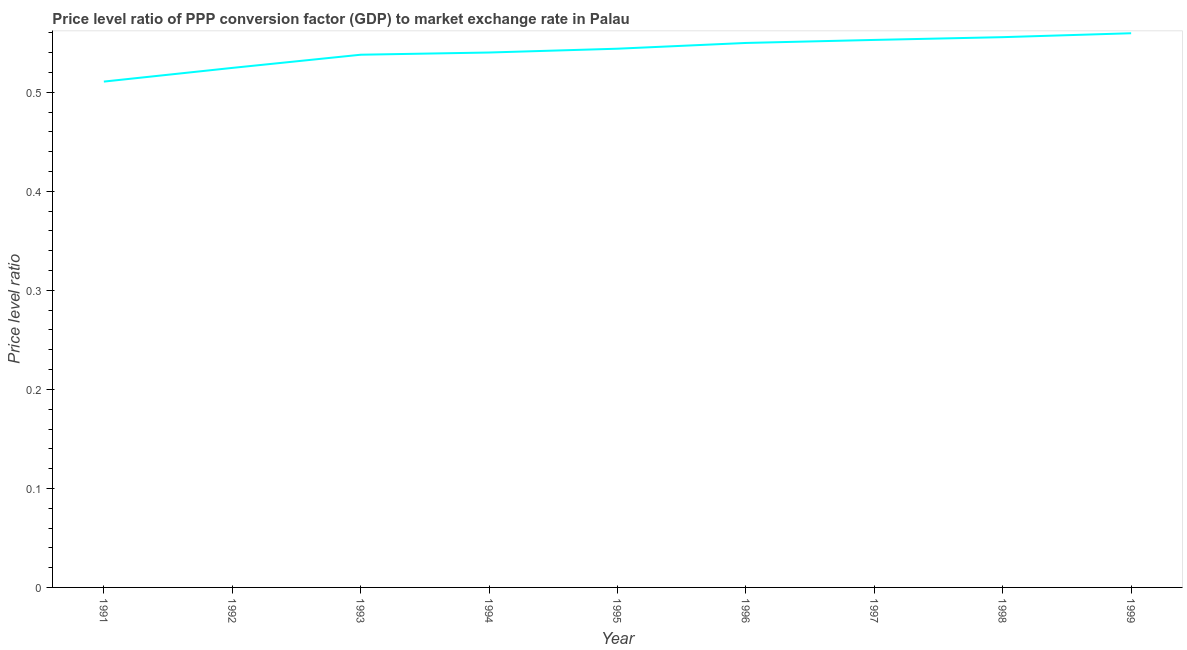What is the price level ratio in 1996?
Your answer should be very brief. 0.55. Across all years, what is the maximum price level ratio?
Offer a terse response. 0.56. Across all years, what is the minimum price level ratio?
Give a very brief answer. 0.51. In which year was the price level ratio minimum?
Offer a terse response. 1991. What is the sum of the price level ratio?
Keep it short and to the point. 4.88. What is the difference between the price level ratio in 1992 and 1995?
Your response must be concise. -0.02. What is the average price level ratio per year?
Make the answer very short. 0.54. What is the median price level ratio?
Offer a terse response. 0.54. What is the ratio of the price level ratio in 1995 to that in 1996?
Your answer should be compact. 0.99. Is the difference between the price level ratio in 1993 and 1997 greater than the difference between any two years?
Your answer should be compact. No. What is the difference between the highest and the second highest price level ratio?
Your answer should be very brief. 0. What is the difference between the highest and the lowest price level ratio?
Your answer should be very brief. 0.05. Does the price level ratio monotonically increase over the years?
Give a very brief answer. Yes. What is the difference between two consecutive major ticks on the Y-axis?
Your response must be concise. 0.1. Are the values on the major ticks of Y-axis written in scientific E-notation?
Ensure brevity in your answer.  No. What is the title of the graph?
Provide a succinct answer. Price level ratio of PPP conversion factor (GDP) to market exchange rate in Palau. What is the label or title of the Y-axis?
Provide a succinct answer. Price level ratio. What is the Price level ratio of 1991?
Your answer should be compact. 0.51. What is the Price level ratio in 1992?
Your answer should be very brief. 0.52. What is the Price level ratio of 1993?
Provide a succinct answer. 0.54. What is the Price level ratio of 1994?
Your response must be concise. 0.54. What is the Price level ratio of 1995?
Keep it short and to the point. 0.54. What is the Price level ratio of 1996?
Give a very brief answer. 0.55. What is the Price level ratio of 1997?
Your response must be concise. 0.55. What is the Price level ratio of 1998?
Your response must be concise. 0.56. What is the Price level ratio in 1999?
Your answer should be very brief. 0.56. What is the difference between the Price level ratio in 1991 and 1992?
Your response must be concise. -0.01. What is the difference between the Price level ratio in 1991 and 1993?
Your response must be concise. -0.03. What is the difference between the Price level ratio in 1991 and 1994?
Offer a very short reply. -0.03. What is the difference between the Price level ratio in 1991 and 1995?
Your response must be concise. -0.03. What is the difference between the Price level ratio in 1991 and 1996?
Provide a succinct answer. -0.04. What is the difference between the Price level ratio in 1991 and 1997?
Your answer should be very brief. -0.04. What is the difference between the Price level ratio in 1991 and 1998?
Offer a terse response. -0.04. What is the difference between the Price level ratio in 1991 and 1999?
Provide a short and direct response. -0.05. What is the difference between the Price level ratio in 1992 and 1993?
Your answer should be very brief. -0.01. What is the difference between the Price level ratio in 1992 and 1994?
Ensure brevity in your answer.  -0.02. What is the difference between the Price level ratio in 1992 and 1995?
Ensure brevity in your answer.  -0.02. What is the difference between the Price level ratio in 1992 and 1996?
Ensure brevity in your answer.  -0.03. What is the difference between the Price level ratio in 1992 and 1997?
Your answer should be very brief. -0.03. What is the difference between the Price level ratio in 1992 and 1998?
Your response must be concise. -0.03. What is the difference between the Price level ratio in 1992 and 1999?
Make the answer very short. -0.04. What is the difference between the Price level ratio in 1993 and 1994?
Offer a very short reply. -0. What is the difference between the Price level ratio in 1993 and 1995?
Keep it short and to the point. -0.01. What is the difference between the Price level ratio in 1993 and 1996?
Offer a terse response. -0.01. What is the difference between the Price level ratio in 1993 and 1997?
Your answer should be very brief. -0.01. What is the difference between the Price level ratio in 1993 and 1998?
Keep it short and to the point. -0.02. What is the difference between the Price level ratio in 1993 and 1999?
Make the answer very short. -0.02. What is the difference between the Price level ratio in 1994 and 1995?
Offer a very short reply. -0. What is the difference between the Price level ratio in 1994 and 1996?
Your response must be concise. -0.01. What is the difference between the Price level ratio in 1994 and 1997?
Provide a succinct answer. -0.01. What is the difference between the Price level ratio in 1994 and 1998?
Your response must be concise. -0.02. What is the difference between the Price level ratio in 1994 and 1999?
Keep it short and to the point. -0.02. What is the difference between the Price level ratio in 1995 and 1996?
Keep it short and to the point. -0.01. What is the difference between the Price level ratio in 1995 and 1997?
Your answer should be compact. -0.01. What is the difference between the Price level ratio in 1995 and 1998?
Provide a short and direct response. -0.01. What is the difference between the Price level ratio in 1995 and 1999?
Your answer should be very brief. -0.02. What is the difference between the Price level ratio in 1996 and 1997?
Your answer should be compact. -0. What is the difference between the Price level ratio in 1996 and 1998?
Offer a very short reply. -0.01. What is the difference between the Price level ratio in 1996 and 1999?
Offer a terse response. -0.01. What is the difference between the Price level ratio in 1997 and 1998?
Keep it short and to the point. -0. What is the difference between the Price level ratio in 1997 and 1999?
Your answer should be compact. -0.01. What is the difference between the Price level ratio in 1998 and 1999?
Offer a very short reply. -0. What is the ratio of the Price level ratio in 1991 to that in 1994?
Your answer should be compact. 0.95. What is the ratio of the Price level ratio in 1991 to that in 1995?
Make the answer very short. 0.94. What is the ratio of the Price level ratio in 1991 to that in 1996?
Ensure brevity in your answer.  0.93. What is the ratio of the Price level ratio in 1991 to that in 1997?
Provide a short and direct response. 0.92. What is the ratio of the Price level ratio in 1991 to that in 1998?
Provide a succinct answer. 0.92. What is the ratio of the Price level ratio in 1992 to that in 1993?
Your answer should be very brief. 0.97. What is the ratio of the Price level ratio in 1992 to that in 1995?
Your answer should be very brief. 0.96. What is the ratio of the Price level ratio in 1992 to that in 1996?
Offer a terse response. 0.95. What is the ratio of the Price level ratio in 1992 to that in 1997?
Keep it short and to the point. 0.95. What is the ratio of the Price level ratio in 1992 to that in 1998?
Offer a terse response. 0.94. What is the ratio of the Price level ratio in 1992 to that in 1999?
Your response must be concise. 0.94. What is the ratio of the Price level ratio in 1993 to that in 1998?
Keep it short and to the point. 0.97. What is the ratio of the Price level ratio in 1994 to that in 1996?
Provide a short and direct response. 0.98. What is the ratio of the Price level ratio in 1994 to that in 1998?
Your response must be concise. 0.97. What is the ratio of the Price level ratio in 1994 to that in 1999?
Provide a short and direct response. 0.96. What is the ratio of the Price level ratio in 1995 to that in 1997?
Ensure brevity in your answer.  0.98. What is the ratio of the Price level ratio in 1995 to that in 1999?
Your answer should be compact. 0.97. What is the ratio of the Price level ratio in 1996 to that in 1997?
Keep it short and to the point. 0.99. What is the ratio of the Price level ratio in 1996 to that in 1998?
Your answer should be compact. 0.99. What is the ratio of the Price level ratio in 1996 to that in 1999?
Make the answer very short. 0.98. What is the ratio of the Price level ratio in 1997 to that in 1998?
Keep it short and to the point. 0.99. What is the ratio of the Price level ratio in 1998 to that in 1999?
Provide a short and direct response. 0.99. 